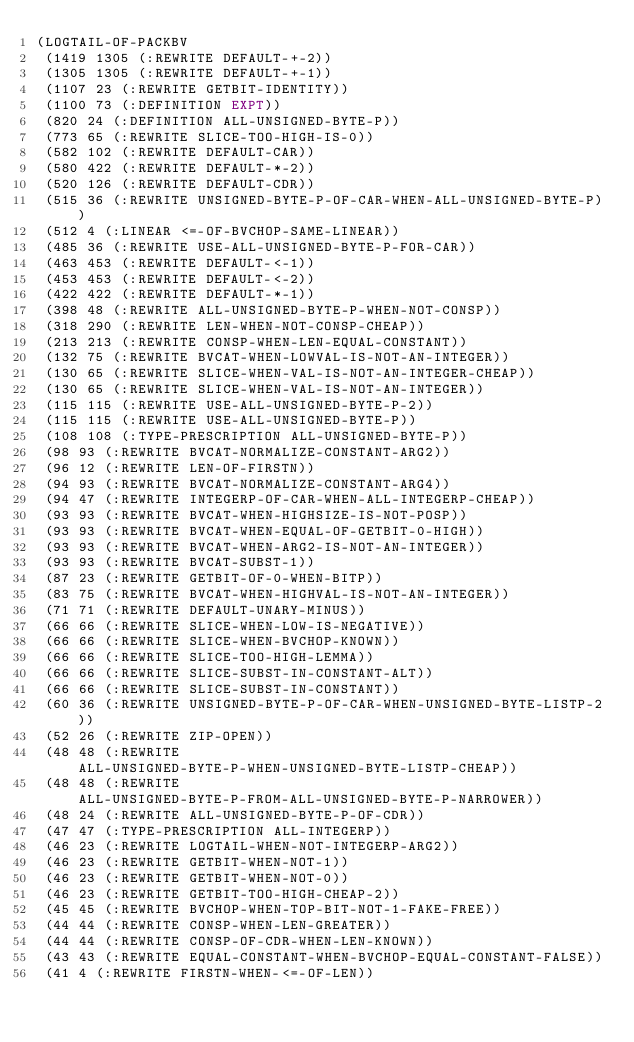<code> <loc_0><loc_0><loc_500><loc_500><_Lisp_>(LOGTAIL-OF-PACKBV
 (1419 1305 (:REWRITE DEFAULT-+-2))
 (1305 1305 (:REWRITE DEFAULT-+-1))
 (1107 23 (:REWRITE GETBIT-IDENTITY))
 (1100 73 (:DEFINITION EXPT))
 (820 24 (:DEFINITION ALL-UNSIGNED-BYTE-P))
 (773 65 (:REWRITE SLICE-TOO-HIGH-IS-0))
 (582 102 (:REWRITE DEFAULT-CAR))
 (580 422 (:REWRITE DEFAULT-*-2))
 (520 126 (:REWRITE DEFAULT-CDR))
 (515 36 (:REWRITE UNSIGNED-BYTE-P-OF-CAR-WHEN-ALL-UNSIGNED-BYTE-P))
 (512 4 (:LINEAR <=-OF-BVCHOP-SAME-LINEAR))
 (485 36 (:REWRITE USE-ALL-UNSIGNED-BYTE-P-FOR-CAR))
 (463 453 (:REWRITE DEFAULT-<-1))
 (453 453 (:REWRITE DEFAULT-<-2))
 (422 422 (:REWRITE DEFAULT-*-1))
 (398 48 (:REWRITE ALL-UNSIGNED-BYTE-P-WHEN-NOT-CONSP))
 (318 290 (:REWRITE LEN-WHEN-NOT-CONSP-CHEAP))
 (213 213 (:REWRITE CONSP-WHEN-LEN-EQUAL-CONSTANT))
 (132 75 (:REWRITE BVCAT-WHEN-LOWVAL-IS-NOT-AN-INTEGER))
 (130 65 (:REWRITE SLICE-WHEN-VAL-IS-NOT-AN-INTEGER-CHEAP))
 (130 65 (:REWRITE SLICE-WHEN-VAL-IS-NOT-AN-INTEGER))
 (115 115 (:REWRITE USE-ALL-UNSIGNED-BYTE-P-2))
 (115 115 (:REWRITE USE-ALL-UNSIGNED-BYTE-P))
 (108 108 (:TYPE-PRESCRIPTION ALL-UNSIGNED-BYTE-P))
 (98 93 (:REWRITE BVCAT-NORMALIZE-CONSTANT-ARG2))
 (96 12 (:REWRITE LEN-OF-FIRSTN))
 (94 93 (:REWRITE BVCAT-NORMALIZE-CONSTANT-ARG4))
 (94 47 (:REWRITE INTEGERP-OF-CAR-WHEN-ALL-INTEGERP-CHEAP))
 (93 93 (:REWRITE BVCAT-WHEN-HIGHSIZE-IS-NOT-POSP))
 (93 93 (:REWRITE BVCAT-WHEN-EQUAL-OF-GETBIT-0-HIGH))
 (93 93 (:REWRITE BVCAT-WHEN-ARG2-IS-NOT-AN-INTEGER))
 (93 93 (:REWRITE BVCAT-SUBST-1))
 (87 23 (:REWRITE GETBIT-OF-0-WHEN-BITP))
 (83 75 (:REWRITE BVCAT-WHEN-HIGHVAL-IS-NOT-AN-INTEGER))
 (71 71 (:REWRITE DEFAULT-UNARY-MINUS))
 (66 66 (:REWRITE SLICE-WHEN-LOW-IS-NEGATIVE))
 (66 66 (:REWRITE SLICE-WHEN-BVCHOP-KNOWN))
 (66 66 (:REWRITE SLICE-TOO-HIGH-LEMMA))
 (66 66 (:REWRITE SLICE-SUBST-IN-CONSTANT-ALT))
 (66 66 (:REWRITE SLICE-SUBST-IN-CONSTANT))
 (60 36 (:REWRITE UNSIGNED-BYTE-P-OF-CAR-WHEN-UNSIGNED-BYTE-LISTP-2))
 (52 26 (:REWRITE ZIP-OPEN))
 (48 48 (:REWRITE ALL-UNSIGNED-BYTE-P-WHEN-UNSIGNED-BYTE-LISTP-CHEAP))
 (48 48 (:REWRITE ALL-UNSIGNED-BYTE-P-FROM-ALL-UNSIGNED-BYTE-P-NARROWER))
 (48 24 (:REWRITE ALL-UNSIGNED-BYTE-P-OF-CDR))
 (47 47 (:TYPE-PRESCRIPTION ALL-INTEGERP))
 (46 23 (:REWRITE LOGTAIL-WHEN-NOT-INTEGERP-ARG2))
 (46 23 (:REWRITE GETBIT-WHEN-NOT-1))
 (46 23 (:REWRITE GETBIT-WHEN-NOT-0))
 (46 23 (:REWRITE GETBIT-TOO-HIGH-CHEAP-2))
 (45 45 (:REWRITE BVCHOP-WHEN-TOP-BIT-NOT-1-FAKE-FREE))
 (44 44 (:REWRITE CONSP-WHEN-LEN-GREATER))
 (44 44 (:REWRITE CONSP-OF-CDR-WHEN-LEN-KNOWN))
 (43 43 (:REWRITE EQUAL-CONSTANT-WHEN-BVCHOP-EQUAL-CONSTANT-FALSE))
 (41 4 (:REWRITE FIRSTN-WHEN-<=-OF-LEN))</code> 